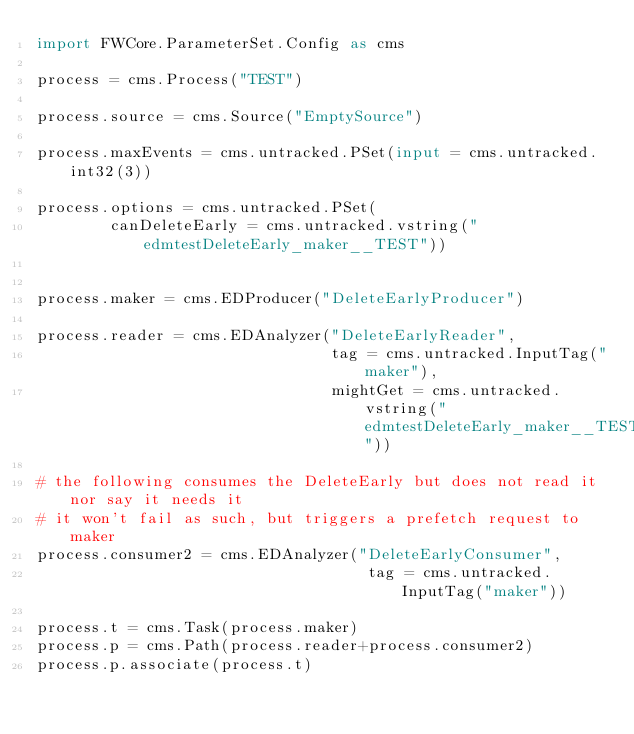<code> <loc_0><loc_0><loc_500><loc_500><_Python_>import FWCore.ParameterSet.Config as cms

process = cms.Process("TEST")

process.source = cms.Source("EmptySource")

process.maxEvents = cms.untracked.PSet(input = cms.untracked.int32(3))

process.options = cms.untracked.PSet(
        canDeleteEarly = cms.untracked.vstring("edmtestDeleteEarly_maker__TEST"))


process.maker = cms.EDProducer("DeleteEarlyProducer")

process.reader = cms.EDAnalyzer("DeleteEarlyReader",
                                tag = cms.untracked.InputTag("maker"),
                                mightGet = cms.untracked.vstring("edmtestDeleteEarly_maker__TEST"))

# the following consumes the DeleteEarly but does not read it nor say it needs it
# it won't fail as such, but triggers a prefetch request to maker
process.consumer2 = cms.EDAnalyzer("DeleteEarlyConsumer",
                                    tag = cms.untracked.InputTag("maker"))

process.t = cms.Task(process.maker)
process.p = cms.Path(process.reader+process.consumer2)
process.p.associate(process.t)
</code> 